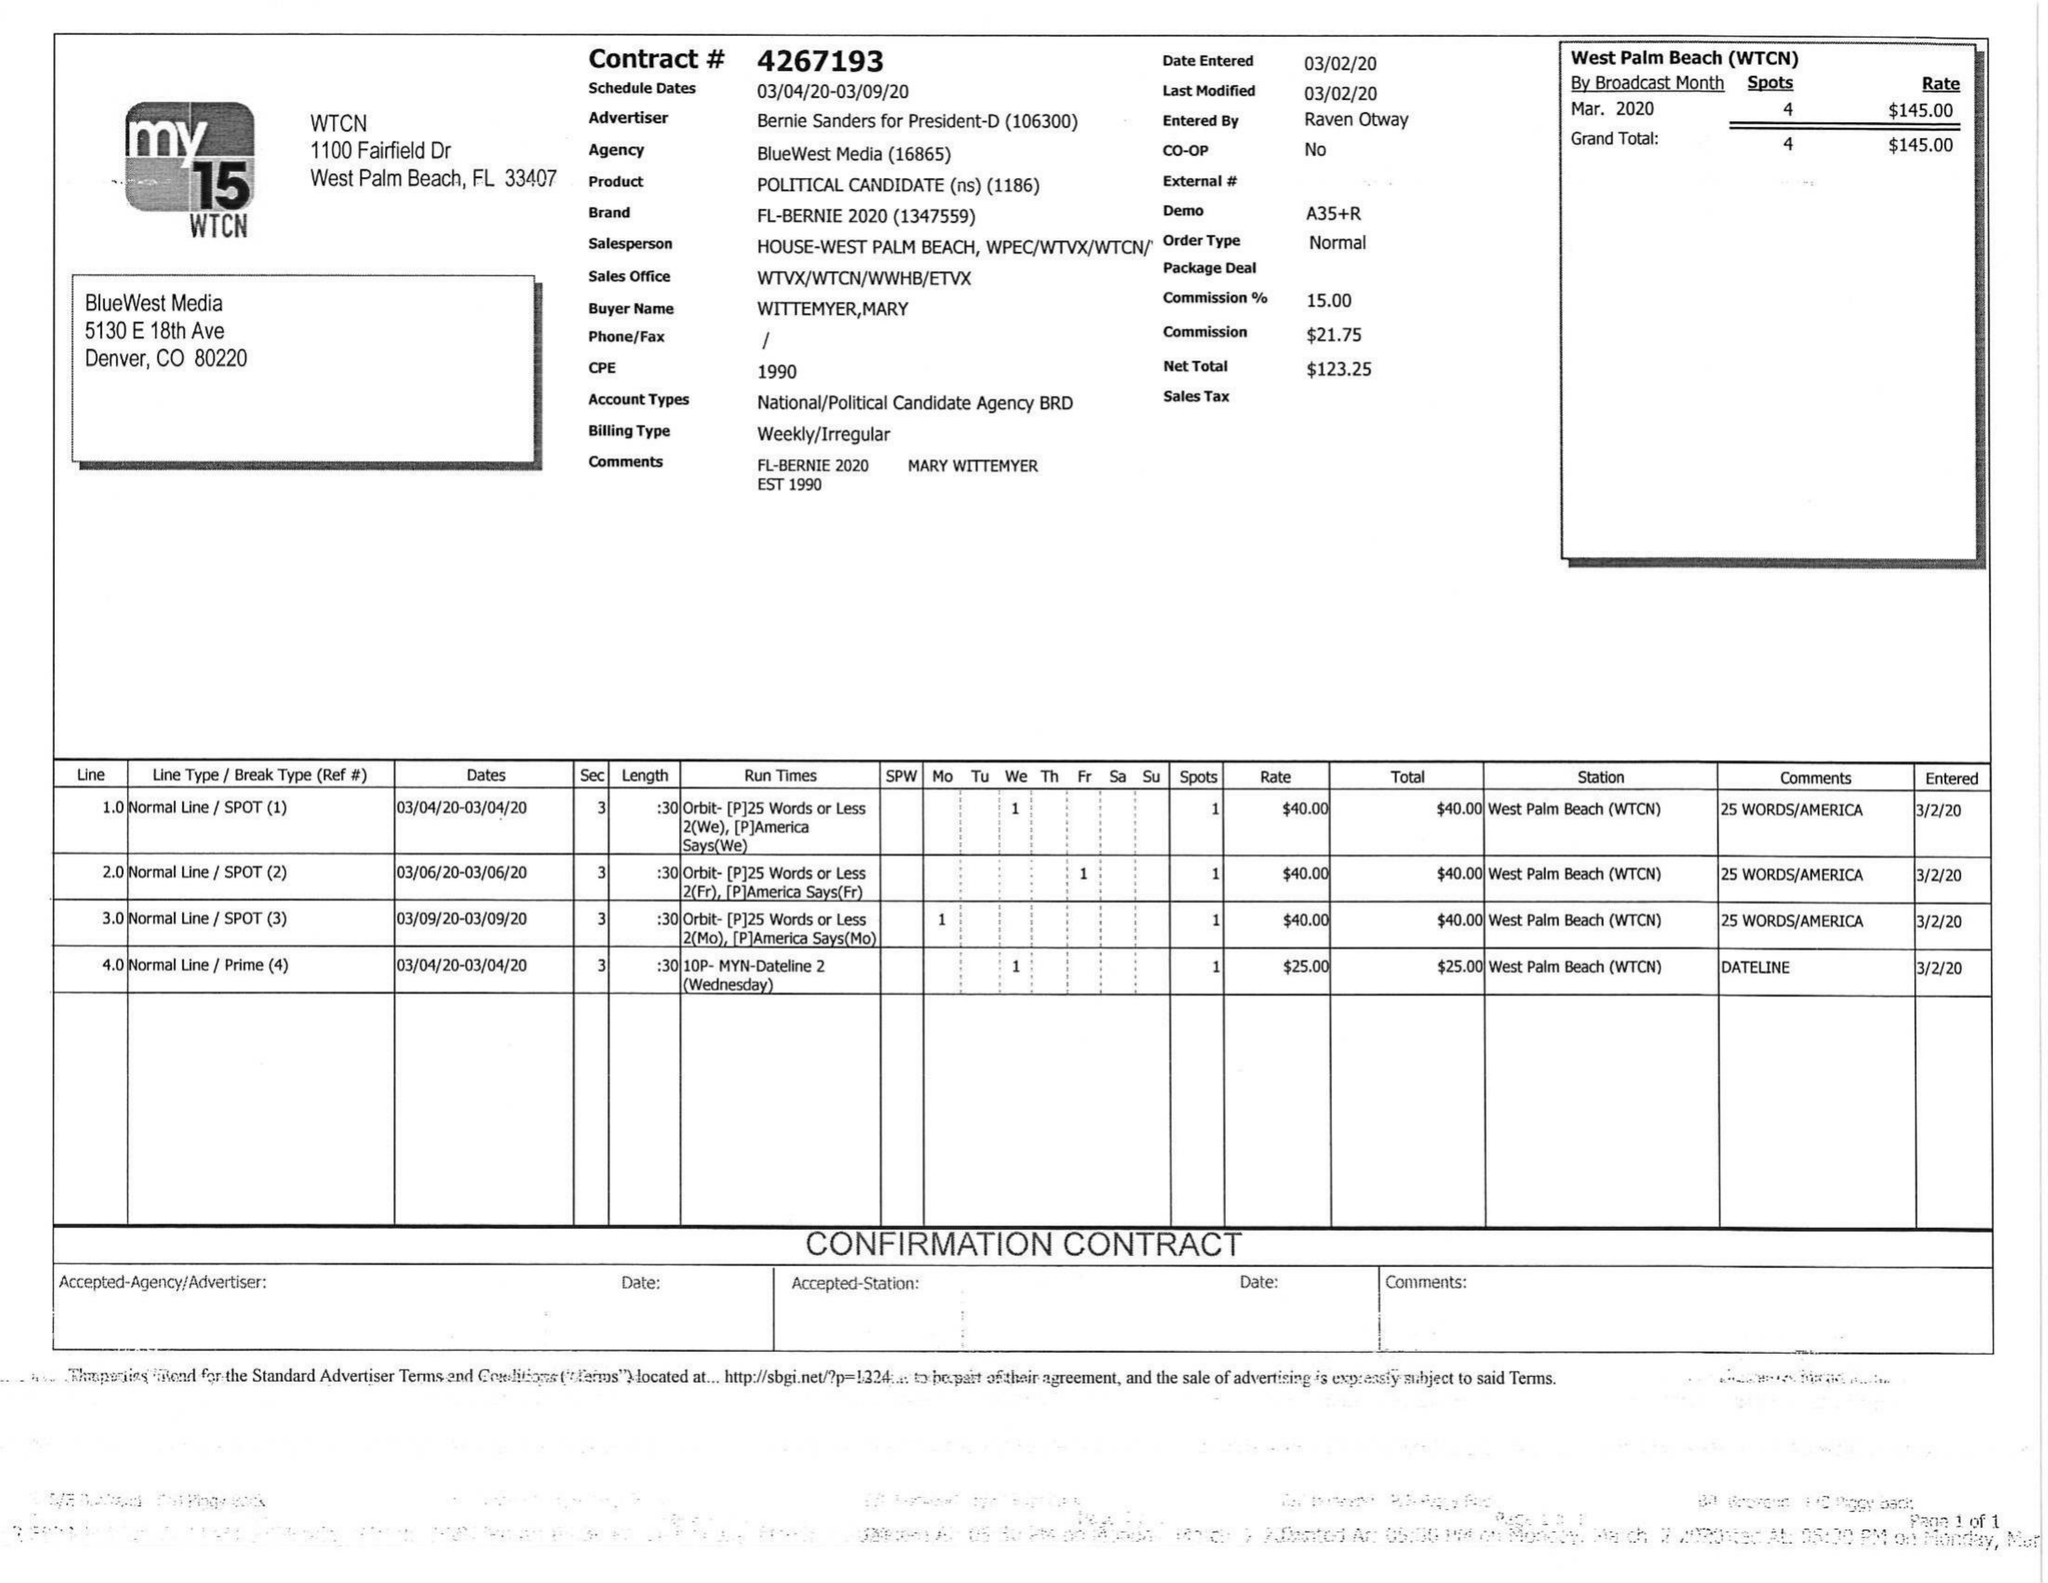What is the value for the flight_from?
Answer the question using a single word or phrase. 03/04/20 